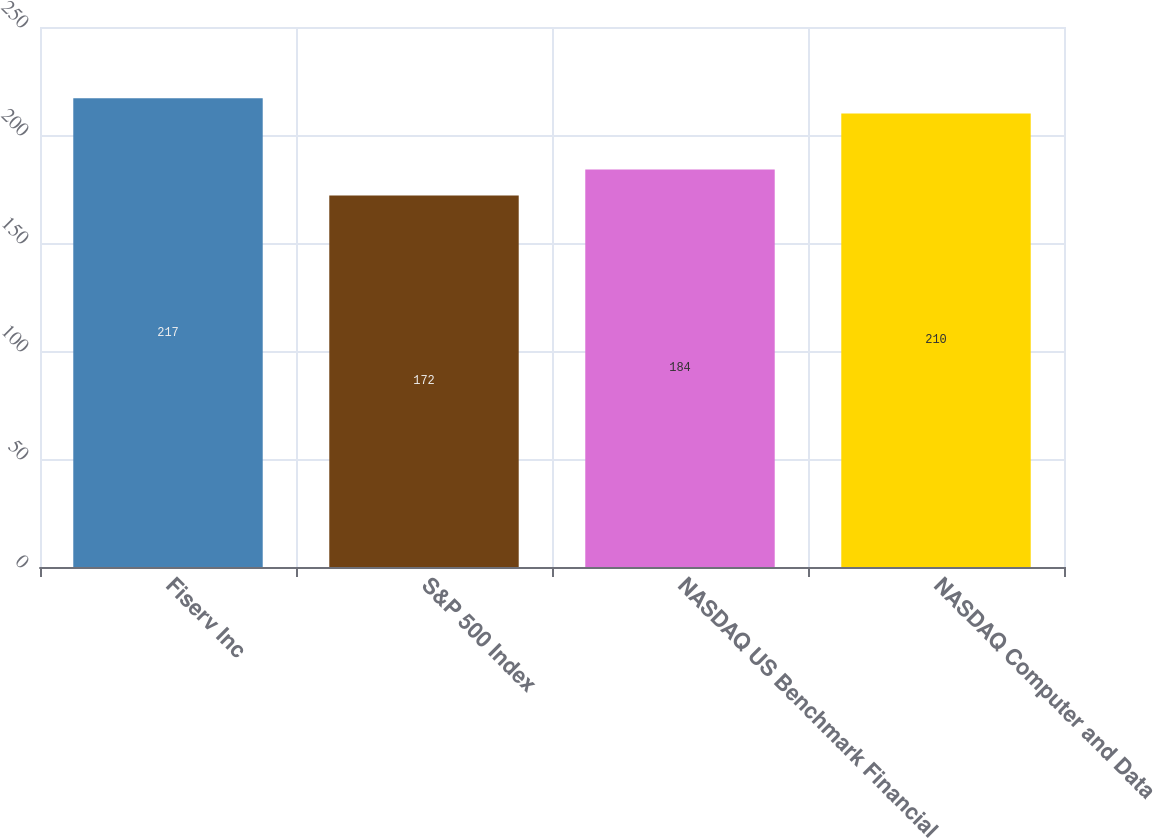Convert chart. <chart><loc_0><loc_0><loc_500><loc_500><bar_chart><fcel>Fiserv Inc<fcel>S&P 500 Index<fcel>NASDAQ US Benchmark Financial<fcel>NASDAQ Computer and Data<nl><fcel>217<fcel>172<fcel>184<fcel>210<nl></chart> 